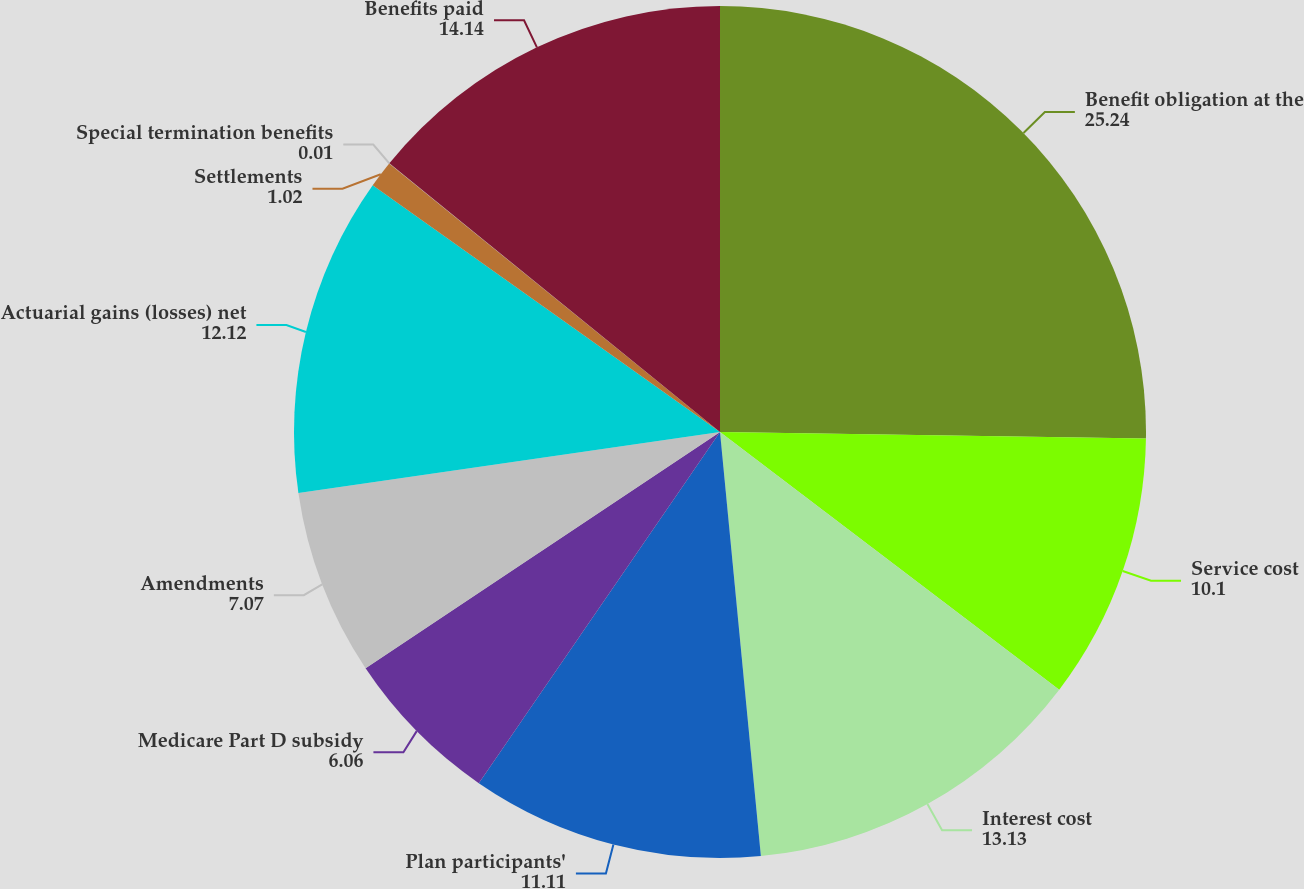Convert chart. <chart><loc_0><loc_0><loc_500><loc_500><pie_chart><fcel>Benefit obligation at the<fcel>Service cost<fcel>Interest cost<fcel>Plan participants'<fcel>Medicare Part D subsidy<fcel>Amendments<fcel>Actuarial gains (losses) net<fcel>Settlements<fcel>Special termination benefits<fcel>Benefits paid<nl><fcel>25.24%<fcel>10.1%<fcel>13.13%<fcel>11.11%<fcel>6.06%<fcel>7.07%<fcel>12.12%<fcel>1.02%<fcel>0.01%<fcel>14.14%<nl></chart> 